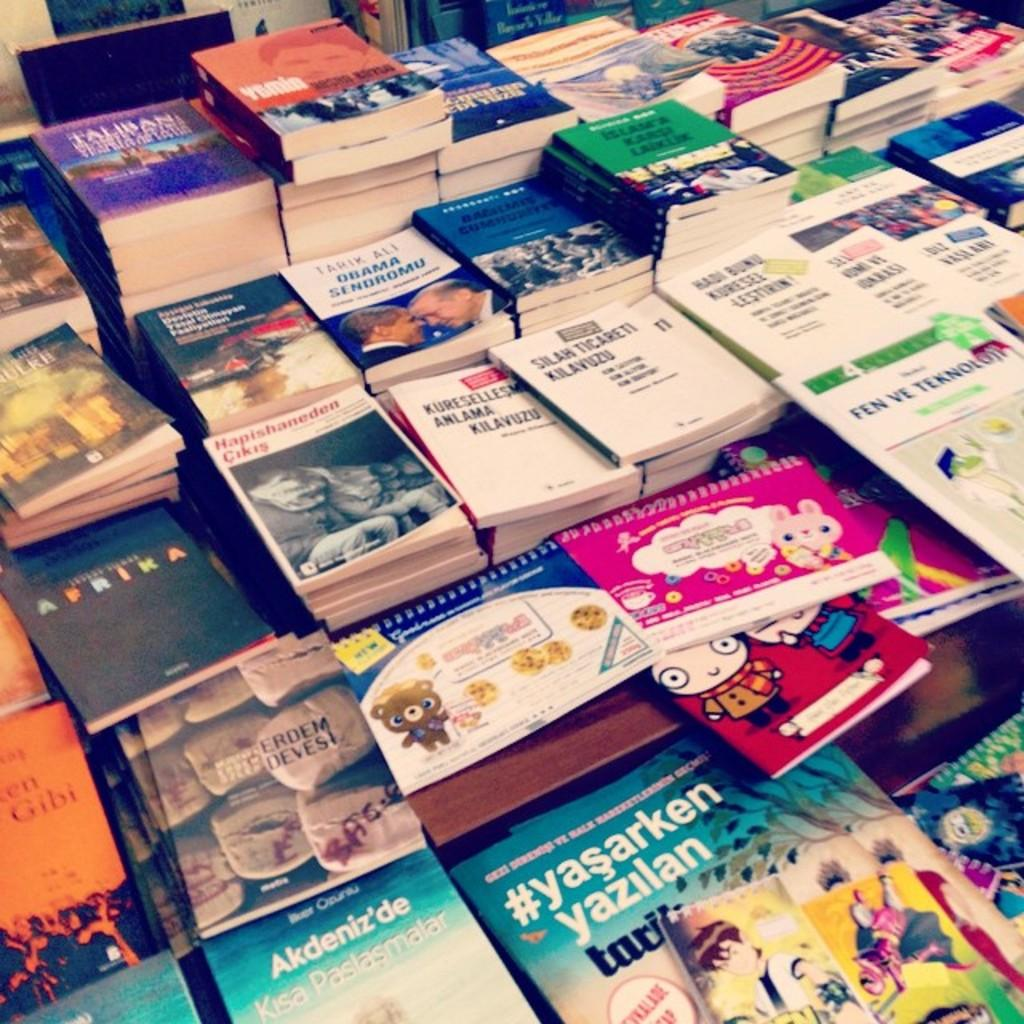<image>
Provide a brief description of the given image. The name Yazilan is on a book among other books 